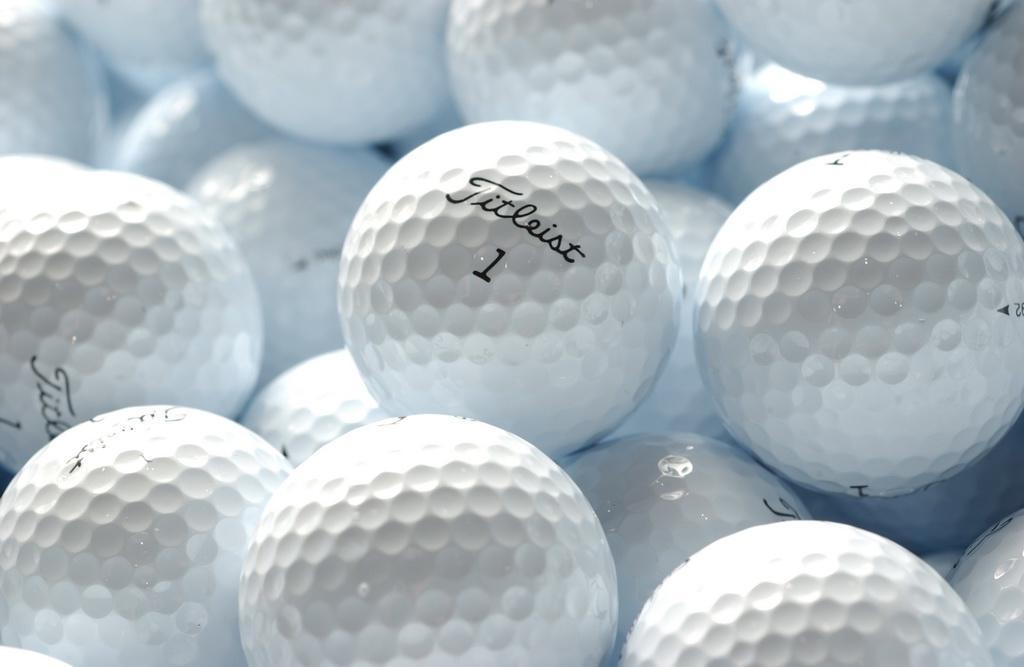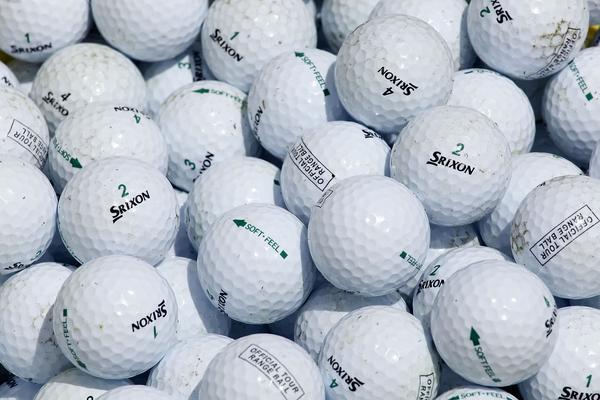The first image is the image on the left, the second image is the image on the right. Considering the images on both sides, is "There is visible dirt on at least three golf balls." valid? Answer yes or no. No. The first image is the image on the left, the second image is the image on the right. Analyze the images presented: Is the assertion "Images show only white balls, and no image contains a golf club." valid? Answer yes or no. Yes. 